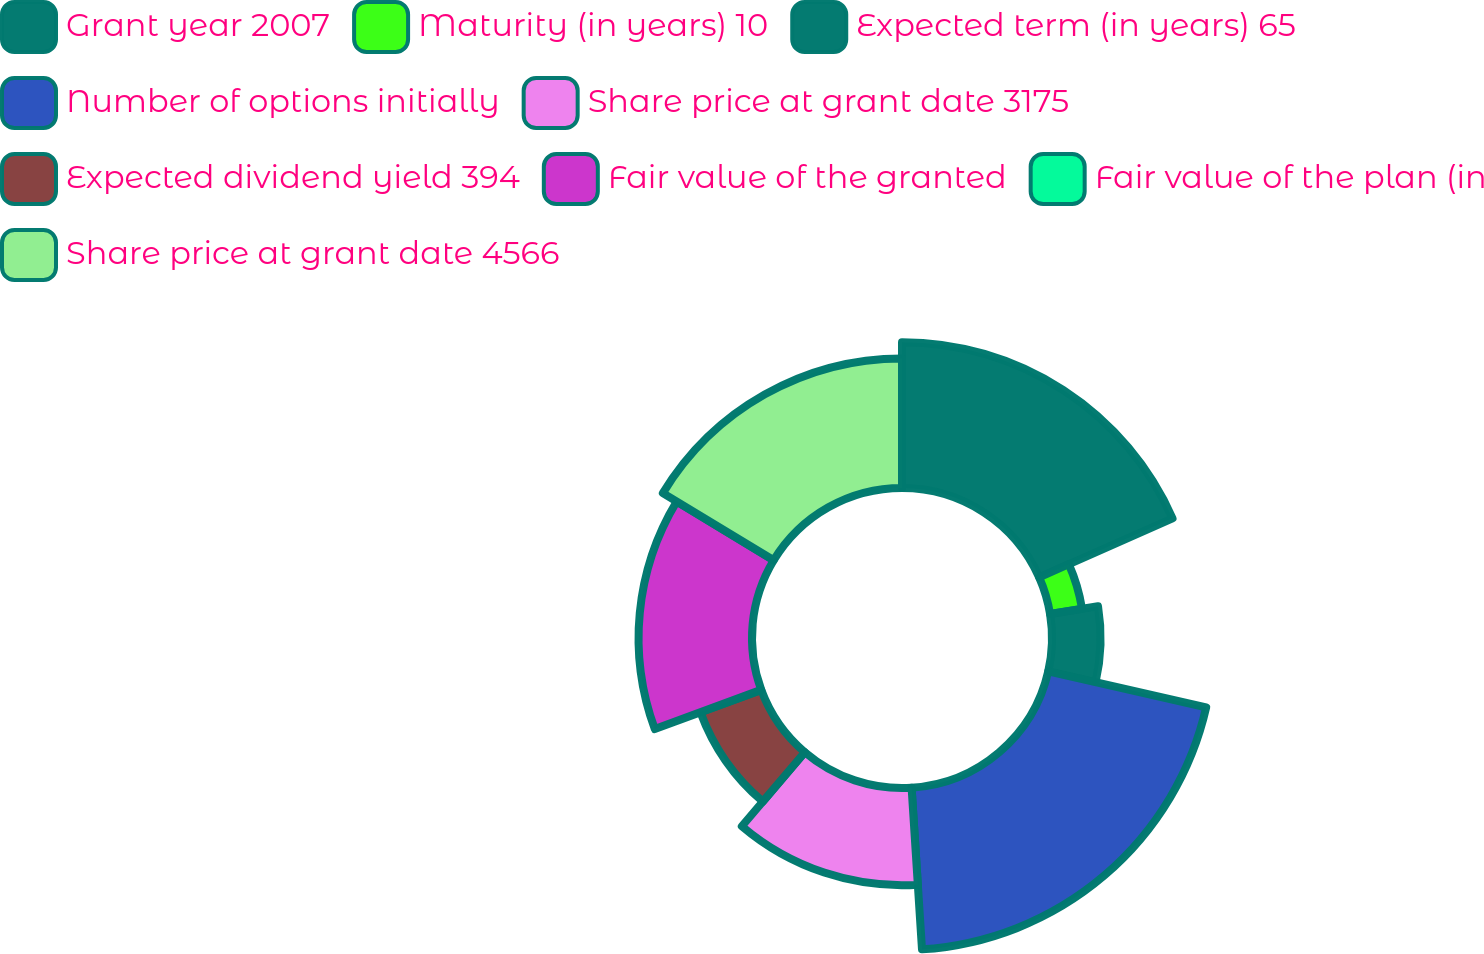Convert chart to OTSL. <chart><loc_0><loc_0><loc_500><loc_500><pie_chart><fcel>Grant year 2007<fcel>Maturity (in years) 10<fcel>Expected term (in years) 65<fcel>Number of options initially<fcel>Share price at grant date 3175<fcel>Expected dividend yield 394<fcel>Fair value of the granted<fcel>Fair value of the plan (in<fcel>Share price at grant date 4566<nl><fcel>18.37%<fcel>4.08%<fcel>6.12%<fcel>20.41%<fcel>12.24%<fcel>8.16%<fcel>14.29%<fcel>0.0%<fcel>16.33%<nl></chart> 